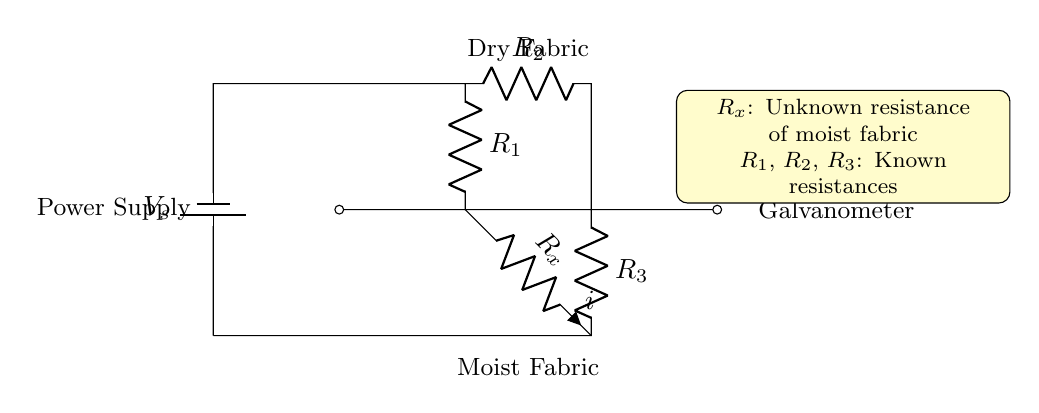What is the type of circuit shown? This is a Wheatstone bridge, which is characterized by its two branches containing resistors and a galvanometer for measuring current.
Answer: Wheatstone bridge What is the purpose of the galvanometer in this circuit? The galvanometer measures the current flowing through it to determine the balance of the bridge, indicating the moisture content in the fabric.
Answer: Measure current What are the known resistances in the circuit? The known resistances are R1, R2, and R3, which are used to compare against the unknown resistance Rx of the moist fabric.
Answer: R1, R2, R3 How many resistors are included in the circuit? There are four resistors in total: R1, R2, R3, and Rx, which allow for the comparison of moisture levels in the fabric.
Answer: Four What does Rx represent in the circuit? Rx represents the unknown resistance of the moist fabric being tested for moisture content against the known resistances.
Answer: Unknown resistance If R1 and R2 are equal, what can be said about the balance of the bridge? If R1 and R2 are equal, and if the galvanometer reads zero current, then the unknown resistance Rx must also equal R3 for balance.
Answer: Equal resistances What is the direction of current flow in the circuit? The current flows from the positive terminal of the power supply, through R1 and R2, and then through the galvanometer, depending on the balance condition of the bridge.
Answer: From positive to negative 